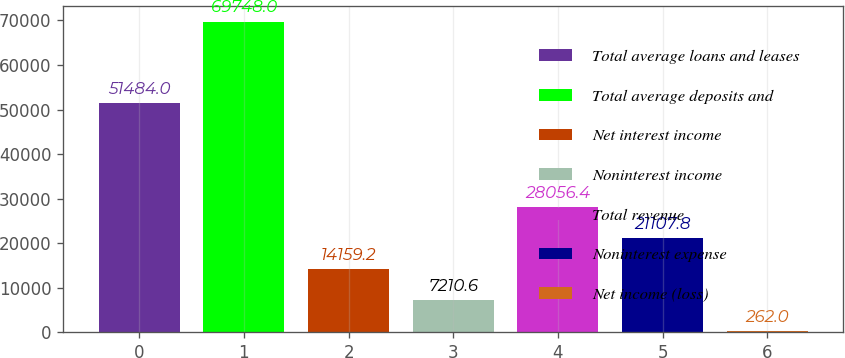Convert chart to OTSL. <chart><loc_0><loc_0><loc_500><loc_500><bar_chart><fcel>Total average loans and leases<fcel>Total average deposits and<fcel>Net interest income<fcel>Noninterest income<fcel>Total revenue<fcel>Noninterest expense<fcel>Net income (loss)<nl><fcel>51484<fcel>69748<fcel>14159.2<fcel>7210.6<fcel>28056.4<fcel>21107.8<fcel>262<nl></chart> 